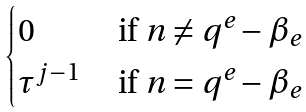<formula> <loc_0><loc_0><loc_500><loc_500>\begin{cases} 0 & \text { if } n \neq q ^ { e } - \beta _ { e } \\ \tau ^ { j - 1 } & \text { if } n = q ^ { e } - \beta _ { e } \\ \end{cases}</formula> 